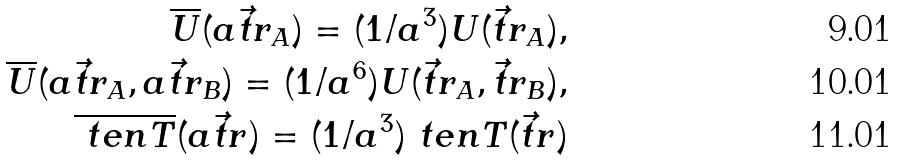<formula> <loc_0><loc_0><loc_500><loc_500>\overline { U } ( a \vec { t } { r } _ { A } ) = ( 1 / a ^ { 3 } ) U ( \vec { t } { r } _ { A } ) , \\ \overline { U } ( a \vec { t } { r } _ { A } , a \vec { t } { r } _ { B } ) = ( 1 / a ^ { 6 } ) U ( \vec { t } { r } _ { A } , \vec { t } { r } _ { B } ) , \\ \overline { \ t e n { T } } ( a \vec { t } { r } ) = ( 1 / a ^ { 3 } ) \ t e n { T } ( \vec { t } { r } )</formula> 